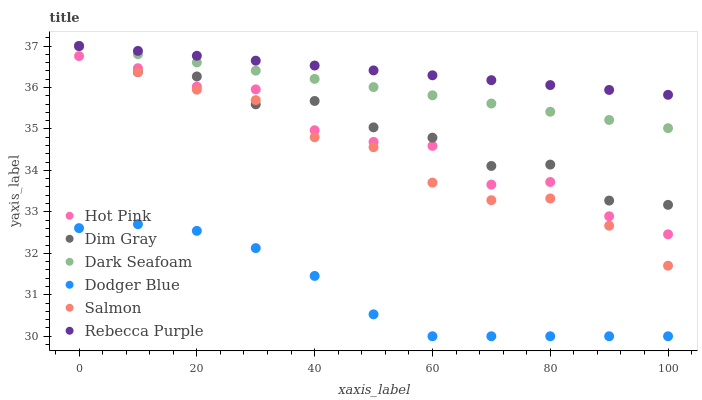Does Dodger Blue have the minimum area under the curve?
Answer yes or no. Yes. Does Rebecca Purple have the maximum area under the curve?
Answer yes or no. Yes. Does Hot Pink have the minimum area under the curve?
Answer yes or no. No. Does Hot Pink have the maximum area under the curve?
Answer yes or no. No. Is Dark Seafoam the smoothest?
Answer yes or no. Yes. Is Dim Gray the roughest?
Answer yes or no. Yes. Is Hot Pink the smoothest?
Answer yes or no. No. Is Hot Pink the roughest?
Answer yes or no. No. Does Dodger Blue have the lowest value?
Answer yes or no. Yes. Does Hot Pink have the lowest value?
Answer yes or no. No. Does Rebecca Purple have the highest value?
Answer yes or no. Yes. Does Hot Pink have the highest value?
Answer yes or no. No. Is Dodger Blue less than Rebecca Purple?
Answer yes or no. Yes. Is Rebecca Purple greater than Hot Pink?
Answer yes or no. Yes. Does Dark Seafoam intersect Dim Gray?
Answer yes or no. Yes. Is Dark Seafoam less than Dim Gray?
Answer yes or no. No. Is Dark Seafoam greater than Dim Gray?
Answer yes or no. No. Does Dodger Blue intersect Rebecca Purple?
Answer yes or no. No. 